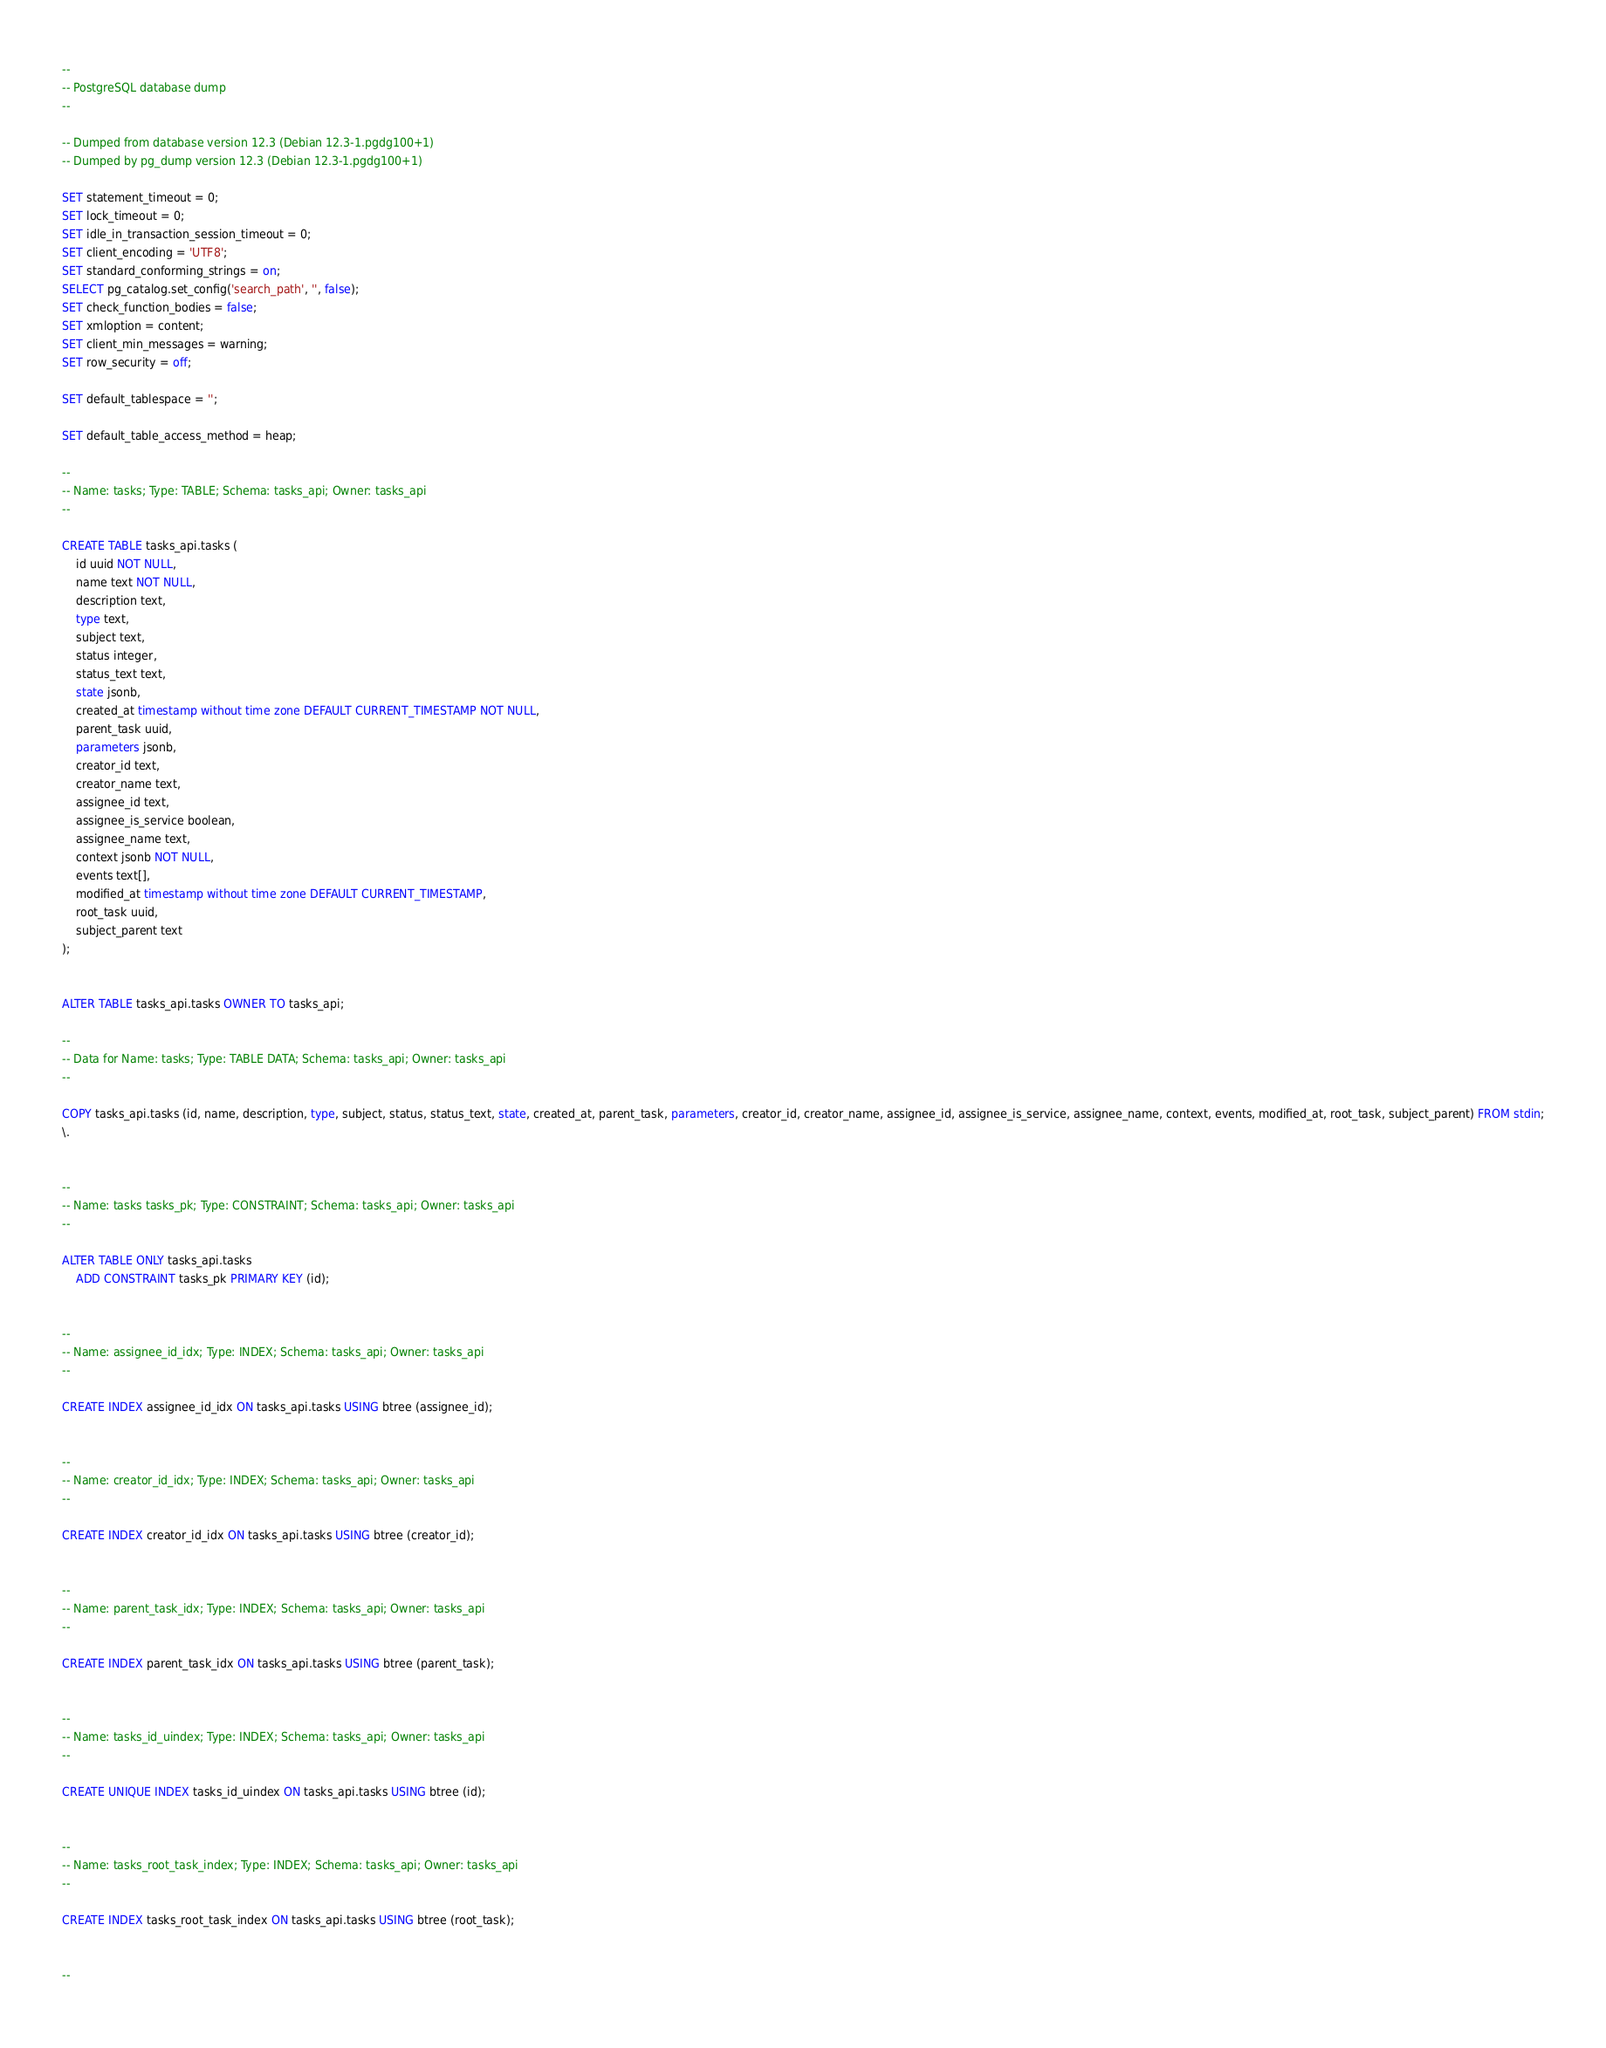Convert code to text. <code><loc_0><loc_0><loc_500><loc_500><_SQL_>--
-- PostgreSQL database dump
--

-- Dumped from database version 12.3 (Debian 12.3-1.pgdg100+1)
-- Dumped by pg_dump version 12.3 (Debian 12.3-1.pgdg100+1)

SET statement_timeout = 0;
SET lock_timeout = 0;
SET idle_in_transaction_session_timeout = 0;
SET client_encoding = 'UTF8';
SET standard_conforming_strings = on;
SELECT pg_catalog.set_config('search_path', '', false);
SET check_function_bodies = false;
SET xmloption = content;
SET client_min_messages = warning;
SET row_security = off;

SET default_tablespace = '';

SET default_table_access_method = heap;

--
-- Name: tasks; Type: TABLE; Schema: tasks_api; Owner: tasks_api
--

CREATE TABLE tasks_api.tasks (
    id uuid NOT NULL,
    name text NOT NULL,
    description text,
    type text,
    subject text,
    status integer,
    status_text text,
    state jsonb,
    created_at timestamp without time zone DEFAULT CURRENT_TIMESTAMP NOT NULL,
    parent_task uuid,
    parameters jsonb,
    creator_id text,
    creator_name text,
    assignee_id text,
    assignee_is_service boolean,
    assignee_name text,
    context jsonb NOT NULL,
    events text[],
    modified_at timestamp without time zone DEFAULT CURRENT_TIMESTAMP,
    root_task uuid,
    subject_parent text
);


ALTER TABLE tasks_api.tasks OWNER TO tasks_api;

--
-- Data for Name: tasks; Type: TABLE DATA; Schema: tasks_api; Owner: tasks_api
--

COPY tasks_api.tasks (id, name, description, type, subject, status, status_text, state, created_at, parent_task, parameters, creator_id, creator_name, assignee_id, assignee_is_service, assignee_name, context, events, modified_at, root_task, subject_parent) FROM stdin;
\.


--
-- Name: tasks tasks_pk; Type: CONSTRAINT; Schema: tasks_api; Owner: tasks_api
--

ALTER TABLE ONLY tasks_api.tasks
    ADD CONSTRAINT tasks_pk PRIMARY KEY (id);


--
-- Name: assignee_id_idx; Type: INDEX; Schema: tasks_api; Owner: tasks_api
--

CREATE INDEX assignee_id_idx ON tasks_api.tasks USING btree (assignee_id);


--
-- Name: creator_id_idx; Type: INDEX; Schema: tasks_api; Owner: tasks_api
--

CREATE INDEX creator_id_idx ON tasks_api.tasks USING btree (creator_id);


--
-- Name: parent_task_idx; Type: INDEX; Schema: tasks_api; Owner: tasks_api
--

CREATE INDEX parent_task_idx ON tasks_api.tasks USING btree (parent_task);


--
-- Name: tasks_id_uindex; Type: INDEX; Schema: tasks_api; Owner: tasks_api
--

CREATE UNIQUE INDEX tasks_id_uindex ON tasks_api.tasks USING btree (id);


--
-- Name: tasks_root_task_index; Type: INDEX; Schema: tasks_api; Owner: tasks_api
--

CREATE INDEX tasks_root_task_index ON tasks_api.tasks USING btree (root_task);


--</code> 